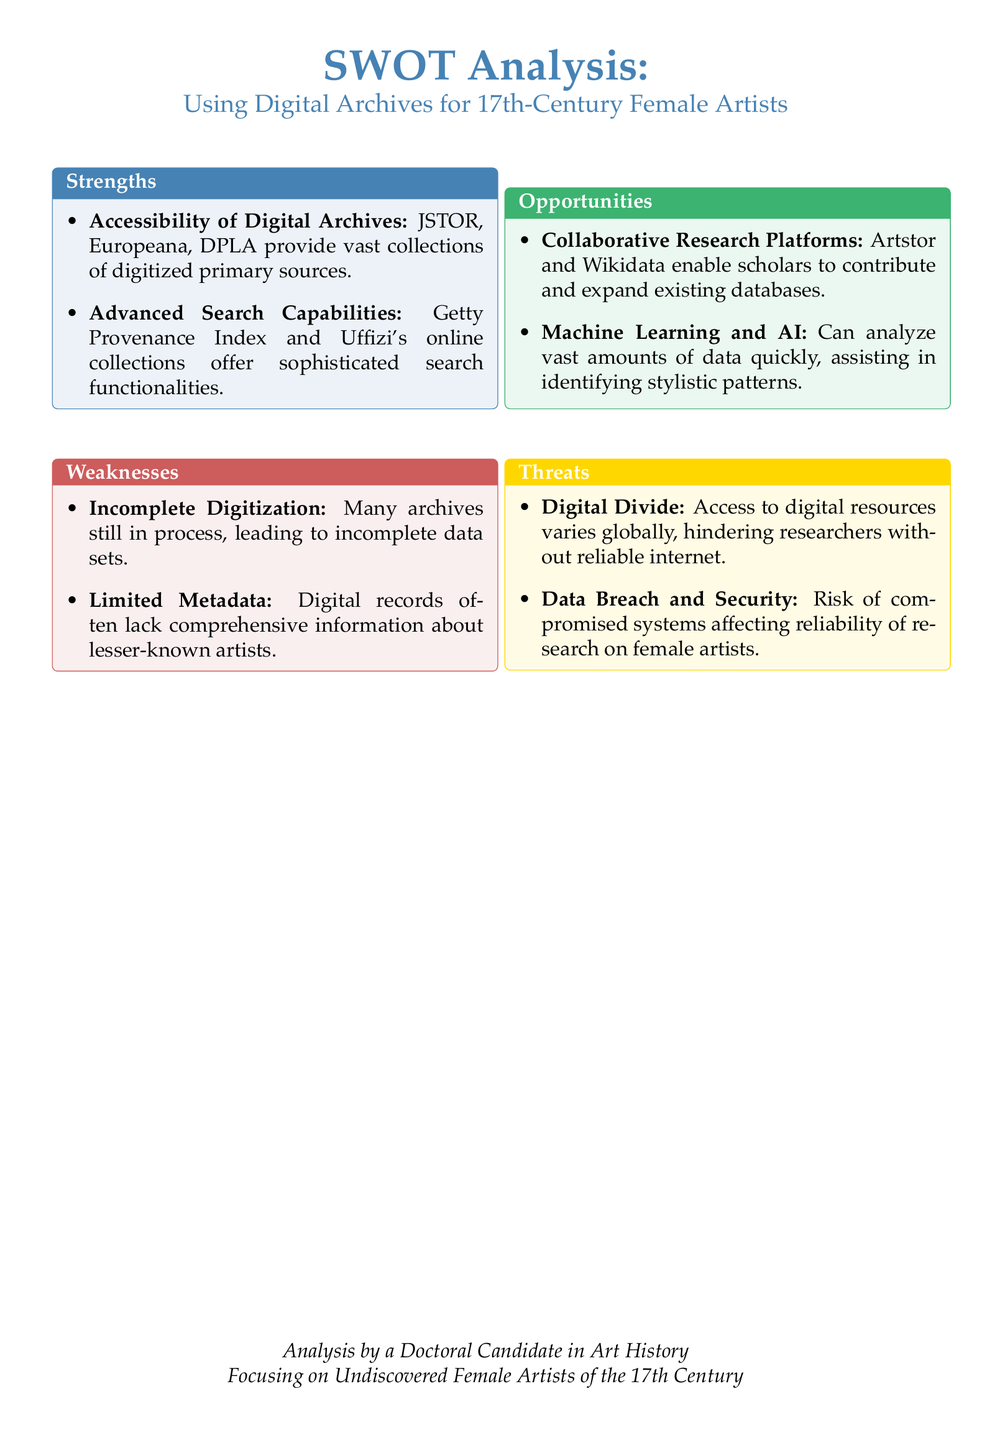what is one of the strengths related to digital archives? The strengths section mentions that JSTOR, Europeana, and DPLA provide vast collections of digitized primary sources.
Answer: Accessibility of Digital Archives what is a weakness identified in the document? The weaknesses section states that many archives are still in process, leading to incomplete data sets.
Answer: Incomplete Digitization name one opportunity mentioned for researching 17th-century female artists. The opportunities section mentions that Artstor and Wikidata enable scholars to contribute and expand existing databases.
Answer: Collaborative Research Platforms what threat associated with digital resources is highlighted? The threats section indicates that access to digital resources varies globally, hindering researchers without reliable internet.
Answer: Digital Divide how many strengths are listed in the document? The strengths section contains two points of information related to its topic.
Answer: 2 what color is used for the weaknesses section header? The weaknesses section uses a red color for its heading.
Answer: myred which digital tool is mentioned for advanced search capabilities? The strengths section specifically mentions the Getty Provenance Index as providing sophisticated search functionalities.
Answer: Getty Provenance Index what kind of analysis can machine learning assist with according to the document? The opportunities section states that machine learning can analyze vast amounts of data quickly, assisting in identifying stylistic patterns.
Answer: Identifying stylistic patterns what document type is being analyzed in this SWOT? The analysis is focusing specifically on using digital archives for 17th-century female artists.
Answer: SWOT Analysis 